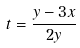Convert formula to latex. <formula><loc_0><loc_0><loc_500><loc_500>t = \frac { y - 3 x } { 2 y }</formula> 